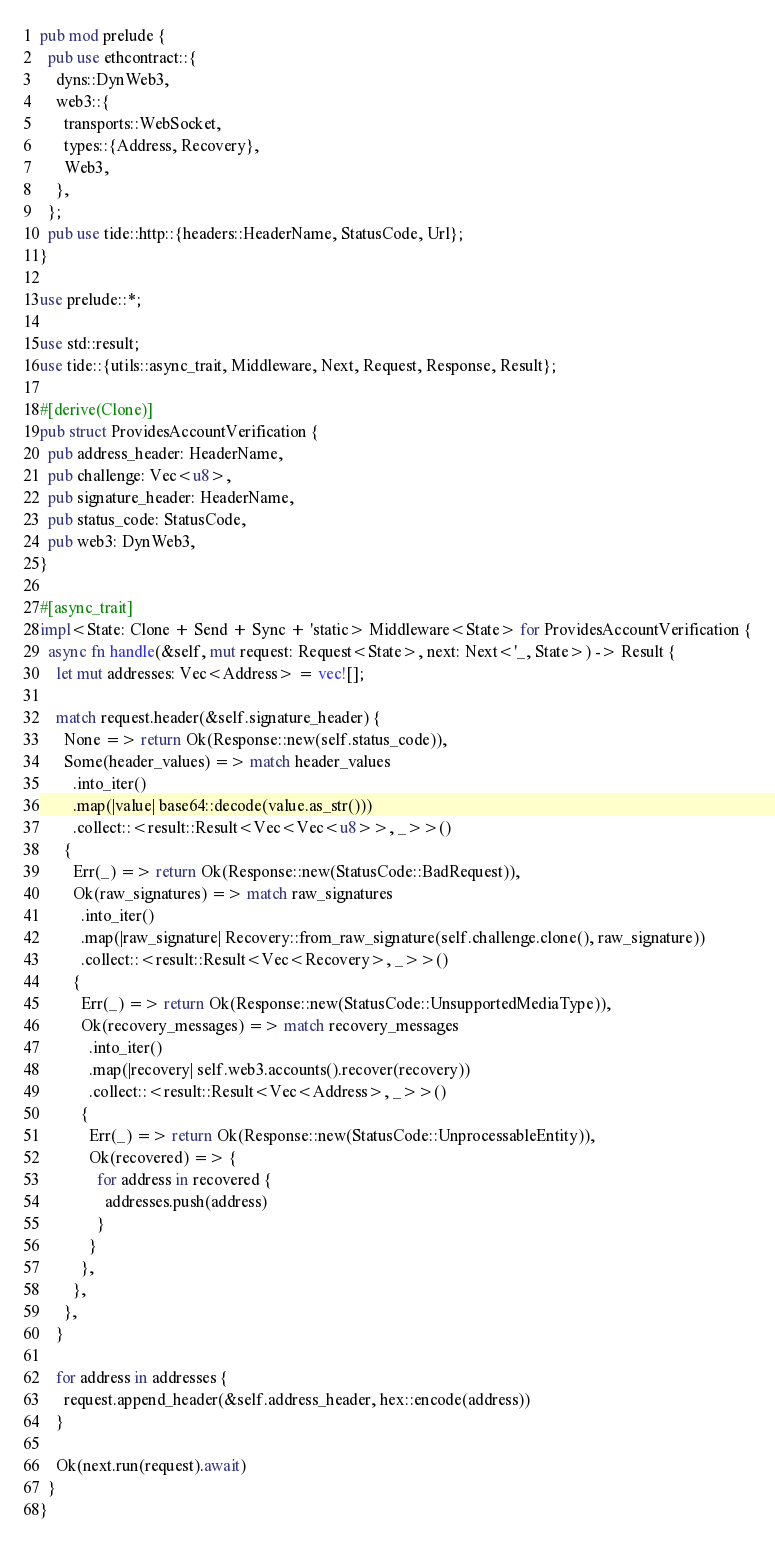<code> <loc_0><loc_0><loc_500><loc_500><_Rust_>pub mod prelude {
  pub use ethcontract::{
    dyns::DynWeb3,
    web3::{
      transports::WebSocket,
      types::{Address, Recovery},
      Web3,
    },
  };
  pub use tide::http::{headers::HeaderName, StatusCode, Url};
}

use prelude::*;

use std::result;
use tide::{utils::async_trait, Middleware, Next, Request, Response, Result};

#[derive(Clone)]
pub struct ProvidesAccountVerification {
  pub address_header: HeaderName,
  pub challenge: Vec<u8>,
  pub signature_header: HeaderName,
  pub status_code: StatusCode,
  pub web3: DynWeb3,
}

#[async_trait]
impl<State: Clone + Send + Sync + 'static> Middleware<State> for ProvidesAccountVerification {
  async fn handle(&self, mut request: Request<State>, next: Next<'_, State>) -> Result {
    let mut addresses: Vec<Address> = vec![];

    match request.header(&self.signature_header) {
      None => return Ok(Response::new(self.status_code)),
      Some(header_values) => match header_values
        .into_iter()
        .map(|value| base64::decode(value.as_str()))
        .collect::<result::Result<Vec<Vec<u8>>, _>>()
      {
        Err(_) => return Ok(Response::new(StatusCode::BadRequest)),
        Ok(raw_signatures) => match raw_signatures
          .into_iter()
          .map(|raw_signature| Recovery::from_raw_signature(self.challenge.clone(), raw_signature))
          .collect::<result::Result<Vec<Recovery>, _>>()
        {
          Err(_) => return Ok(Response::new(StatusCode::UnsupportedMediaType)),
          Ok(recovery_messages) => match recovery_messages
            .into_iter()
            .map(|recovery| self.web3.accounts().recover(recovery))
            .collect::<result::Result<Vec<Address>, _>>()
          {
            Err(_) => return Ok(Response::new(StatusCode::UnprocessableEntity)),
            Ok(recovered) => {
              for address in recovered {
                addresses.push(address)
              }
            }
          },
        },
      },
    }

    for address in addresses {
      request.append_header(&self.address_header, hex::encode(address))
    }

    Ok(next.run(request).await)
  }
}
</code> 